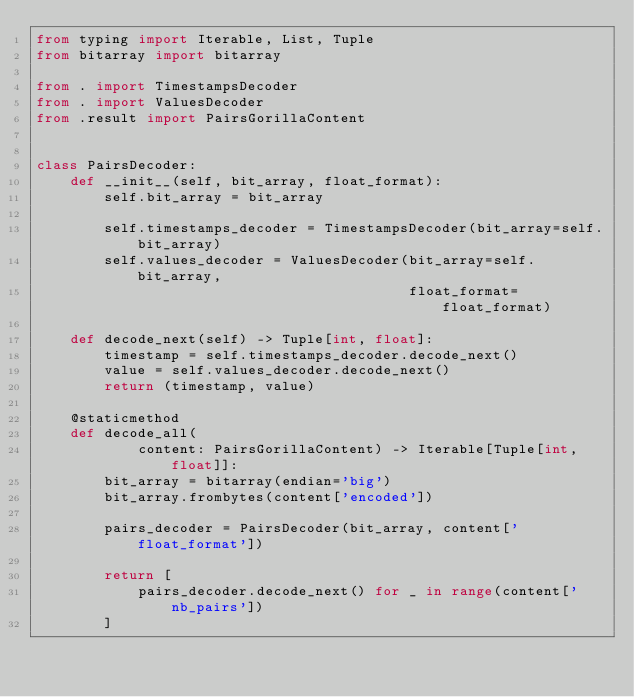<code> <loc_0><loc_0><loc_500><loc_500><_Python_>from typing import Iterable, List, Tuple
from bitarray import bitarray

from . import TimestampsDecoder
from . import ValuesDecoder
from .result import PairsGorillaContent


class PairsDecoder:
    def __init__(self, bit_array, float_format):
        self.bit_array = bit_array

        self.timestamps_decoder = TimestampsDecoder(bit_array=self.bit_array)
        self.values_decoder = ValuesDecoder(bit_array=self.bit_array,
                                            float_format=float_format)

    def decode_next(self) -> Tuple[int, float]:
        timestamp = self.timestamps_decoder.decode_next()
        value = self.values_decoder.decode_next()
        return (timestamp, value)

    @staticmethod
    def decode_all(
            content: PairsGorillaContent) -> Iterable[Tuple[int, float]]:
        bit_array = bitarray(endian='big')
        bit_array.frombytes(content['encoded'])

        pairs_decoder = PairsDecoder(bit_array, content['float_format'])

        return [
            pairs_decoder.decode_next() for _ in range(content['nb_pairs'])
        ]
</code> 